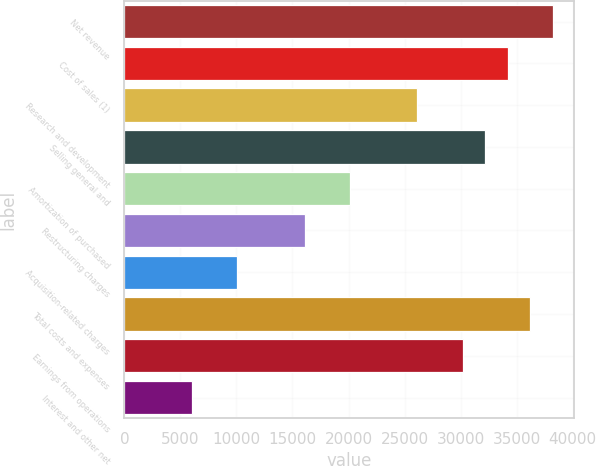Convert chart to OTSL. <chart><loc_0><loc_0><loc_500><loc_500><bar_chart><fcel>Net revenue<fcel>Cost of sales (1)<fcel>Research and development<fcel>Selling general and<fcel>Amortization of purchased<fcel>Restructuring charges<fcel>Acquisition-related charges<fcel>Total costs and expenses<fcel>Earnings from operations<fcel>Interest and other net<nl><fcel>38214.6<fcel>34192<fcel>26146.8<fcel>32180.7<fcel>20113<fcel>16090.4<fcel>10056.5<fcel>36203.3<fcel>30169.4<fcel>6033.95<nl></chart> 